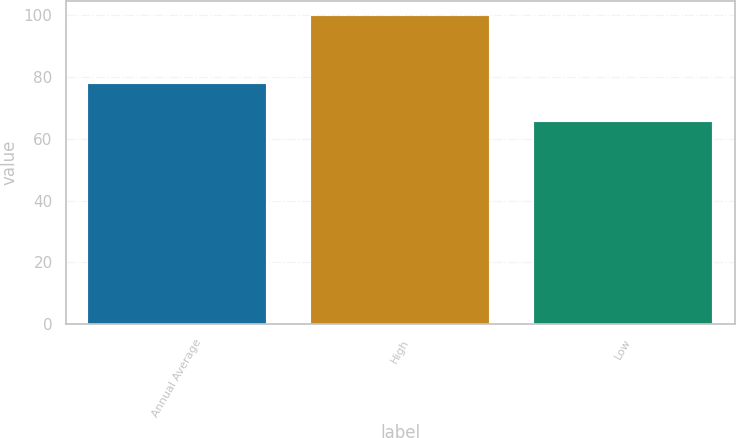Convert chart to OTSL. <chart><loc_0><loc_0><loc_500><loc_500><bar_chart><fcel>Annual Average<fcel>High<fcel>Low<nl><fcel>77.8<fcel>99.8<fcel>65.6<nl></chart> 